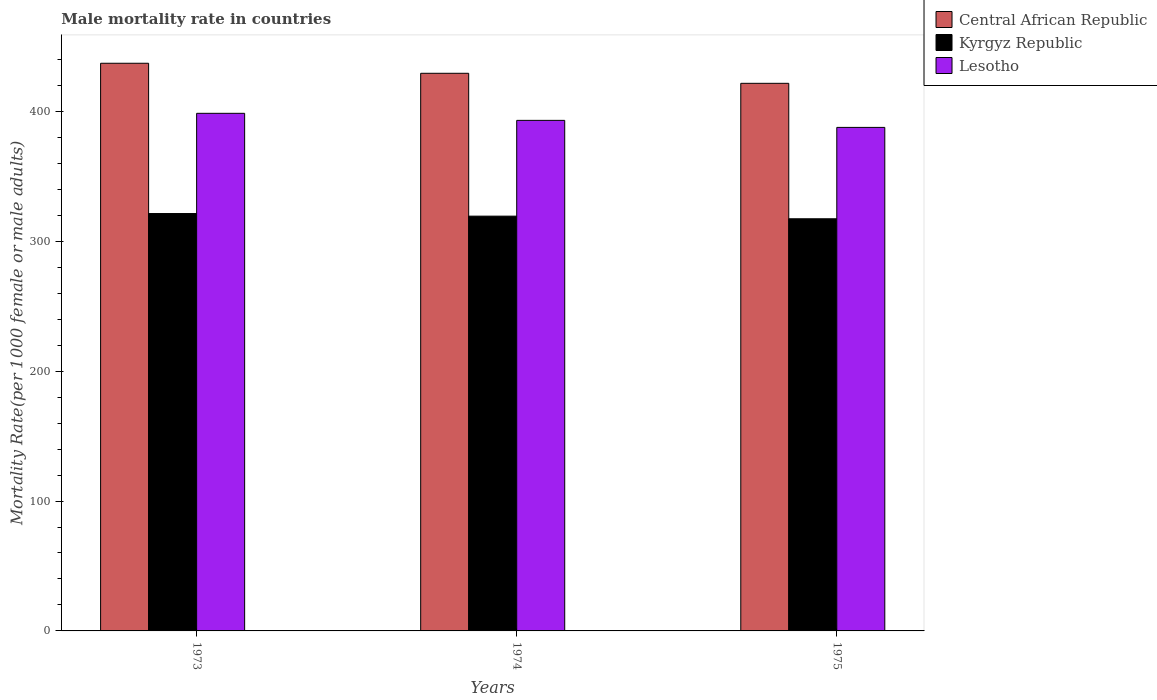What is the label of the 3rd group of bars from the left?
Give a very brief answer. 1975. What is the male mortality rate in Central African Republic in 1974?
Your answer should be very brief. 429.28. Across all years, what is the maximum male mortality rate in Kyrgyz Republic?
Your response must be concise. 321.32. Across all years, what is the minimum male mortality rate in Central African Republic?
Your answer should be compact. 421.56. In which year was the male mortality rate in Kyrgyz Republic maximum?
Make the answer very short. 1973. In which year was the male mortality rate in Kyrgyz Republic minimum?
Your answer should be very brief. 1975. What is the total male mortality rate in Lesotho in the graph?
Ensure brevity in your answer.  1179.13. What is the difference between the male mortality rate in Lesotho in 1974 and that in 1975?
Keep it short and to the point. 5.42. What is the difference between the male mortality rate in Kyrgyz Republic in 1975 and the male mortality rate in Lesotho in 1974?
Your response must be concise. -75.76. What is the average male mortality rate in Kyrgyz Republic per year?
Make the answer very short. 319.3. In the year 1975, what is the difference between the male mortality rate in Lesotho and male mortality rate in Central African Republic?
Make the answer very short. -33.93. In how many years, is the male mortality rate in Central African Republic greater than 180?
Keep it short and to the point. 3. What is the ratio of the male mortality rate in Central African Republic in 1974 to that in 1975?
Give a very brief answer. 1.02. Is the difference between the male mortality rate in Lesotho in 1973 and 1975 greater than the difference between the male mortality rate in Central African Republic in 1973 and 1975?
Keep it short and to the point. No. What is the difference between the highest and the second highest male mortality rate in Lesotho?
Make the answer very short. 5.42. What is the difference between the highest and the lowest male mortality rate in Lesotho?
Your answer should be very brief. 10.83. Is the sum of the male mortality rate in Lesotho in 1973 and 1975 greater than the maximum male mortality rate in Central African Republic across all years?
Make the answer very short. Yes. What does the 2nd bar from the left in 1975 represents?
Give a very brief answer. Kyrgyz Republic. What does the 3rd bar from the right in 1974 represents?
Your response must be concise. Central African Republic. Is it the case that in every year, the sum of the male mortality rate in Kyrgyz Republic and male mortality rate in Central African Republic is greater than the male mortality rate in Lesotho?
Give a very brief answer. Yes. Are all the bars in the graph horizontal?
Offer a terse response. No. Does the graph contain any zero values?
Ensure brevity in your answer.  No. Does the graph contain grids?
Provide a short and direct response. No. Where does the legend appear in the graph?
Keep it short and to the point. Top right. How are the legend labels stacked?
Offer a terse response. Vertical. What is the title of the graph?
Offer a terse response. Male mortality rate in countries. What is the label or title of the X-axis?
Ensure brevity in your answer.  Years. What is the label or title of the Y-axis?
Make the answer very short. Mortality Rate(per 1000 female or male adults). What is the Mortality Rate(per 1000 female or male adults) of Central African Republic in 1973?
Your response must be concise. 437. What is the Mortality Rate(per 1000 female or male adults) of Kyrgyz Republic in 1973?
Provide a short and direct response. 321.32. What is the Mortality Rate(per 1000 female or male adults) in Lesotho in 1973?
Give a very brief answer. 398.46. What is the Mortality Rate(per 1000 female or male adults) of Central African Republic in 1974?
Provide a short and direct response. 429.28. What is the Mortality Rate(per 1000 female or male adults) of Kyrgyz Republic in 1974?
Ensure brevity in your answer.  319.3. What is the Mortality Rate(per 1000 female or male adults) of Lesotho in 1974?
Ensure brevity in your answer.  393.05. What is the Mortality Rate(per 1000 female or male adults) in Central African Republic in 1975?
Your response must be concise. 421.56. What is the Mortality Rate(per 1000 female or male adults) in Kyrgyz Republic in 1975?
Your answer should be compact. 317.28. What is the Mortality Rate(per 1000 female or male adults) of Lesotho in 1975?
Make the answer very short. 387.63. Across all years, what is the maximum Mortality Rate(per 1000 female or male adults) of Central African Republic?
Keep it short and to the point. 437. Across all years, what is the maximum Mortality Rate(per 1000 female or male adults) of Kyrgyz Republic?
Make the answer very short. 321.32. Across all years, what is the maximum Mortality Rate(per 1000 female or male adults) in Lesotho?
Provide a succinct answer. 398.46. Across all years, what is the minimum Mortality Rate(per 1000 female or male adults) of Central African Republic?
Provide a short and direct response. 421.56. Across all years, what is the minimum Mortality Rate(per 1000 female or male adults) of Kyrgyz Republic?
Ensure brevity in your answer.  317.28. Across all years, what is the minimum Mortality Rate(per 1000 female or male adults) in Lesotho?
Keep it short and to the point. 387.63. What is the total Mortality Rate(per 1000 female or male adults) of Central African Republic in the graph?
Your answer should be very brief. 1287.85. What is the total Mortality Rate(per 1000 female or male adults) of Kyrgyz Republic in the graph?
Provide a succinct answer. 957.9. What is the total Mortality Rate(per 1000 female or male adults) in Lesotho in the graph?
Your answer should be compact. 1179.13. What is the difference between the Mortality Rate(per 1000 female or male adults) in Central African Republic in 1973 and that in 1974?
Make the answer very short. 7.72. What is the difference between the Mortality Rate(per 1000 female or male adults) in Kyrgyz Republic in 1973 and that in 1974?
Offer a very short reply. 2.02. What is the difference between the Mortality Rate(per 1000 female or male adults) in Lesotho in 1973 and that in 1974?
Provide a succinct answer. 5.42. What is the difference between the Mortality Rate(per 1000 female or male adults) of Central African Republic in 1973 and that in 1975?
Give a very brief answer. 15.45. What is the difference between the Mortality Rate(per 1000 female or male adults) of Kyrgyz Republic in 1973 and that in 1975?
Offer a terse response. 4.04. What is the difference between the Mortality Rate(per 1000 female or male adults) in Lesotho in 1973 and that in 1975?
Keep it short and to the point. 10.84. What is the difference between the Mortality Rate(per 1000 female or male adults) of Central African Republic in 1974 and that in 1975?
Keep it short and to the point. 7.72. What is the difference between the Mortality Rate(per 1000 female or male adults) of Kyrgyz Republic in 1974 and that in 1975?
Provide a succinct answer. 2.02. What is the difference between the Mortality Rate(per 1000 female or male adults) in Lesotho in 1974 and that in 1975?
Provide a succinct answer. 5.42. What is the difference between the Mortality Rate(per 1000 female or male adults) of Central African Republic in 1973 and the Mortality Rate(per 1000 female or male adults) of Kyrgyz Republic in 1974?
Give a very brief answer. 117.7. What is the difference between the Mortality Rate(per 1000 female or male adults) in Central African Republic in 1973 and the Mortality Rate(per 1000 female or male adults) in Lesotho in 1974?
Provide a succinct answer. 43.96. What is the difference between the Mortality Rate(per 1000 female or male adults) in Kyrgyz Republic in 1973 and the Mortality Rate(per 1000 female or male adults) in Lesotho in 1974?
Offer a terse response. -71.73. What is the difference between the Mortality Rate(per 1000 female or male adults) in Central African Republic in 1973 and the Mortality Rate(per 1000 female or male adults) in Kyrgyz Republic in 1975?
Provide a short and direct response. 119.72. What is the difference between the Mortality Rate(per 1000 female or male adults) in Central African Republic in 1973 and the Mortality Rate(per 1000 female or male adults) in Lesotho in 1975?
Offer a very short reply. 49.38. What is the difference between the Mortality Rate(per 1000 female or male adults) of Kyrgyz Republic in 1973 and the Mortality Rate(per 1000 female or male adults) of Lesotho in 1975?
Make the answer very short. -66.31. What is the difference between the Mortality Rate(per 1000 female or male adults) in Central African Republic in 1974 and the Mortality Rate(per 1000 female or male adults) in Kyrgyz Republic in 1975?
Your answer should be very brief. 112. What is the difference between the Mortality Rate(per 1000 female or male adults) in Central African Republic in 1974 and the Mortality Rate(per 1000 female or male adults) in Lesotho in 1975?
Keep it short and to the point. 41.66. What is the difference between the Mortality Rate(per 1000 female or male adults) of Kyrgyz Republic in 1974 and the Mortality Rate(per 1000 female or male adults) of Lesotho in 1975?
Provide a succinct answer. -68.33. What is the average Mortality Rate(per 1000 female or male adults) in Central African Republic per year?
Provide a short and direct response. 429.28. What is the average Mortality Rate(per 1000 female or male adults) of Kyrgyz Republic per year?
Offer a terse response. 319.3. What is the average Mortality Rate(per 1000 female or male adults) in Lesotho per year?
Make the answer very short. 393.04. In the year 1973, what is the difference between the Mortality Rate(per 1000 female or male adults) of Central African Republic and Mortality Rate(per 1000 female or male adults) of Kyrgyz Republic?
Keep it short and to the point. 115.69. In the year 1973, what is the difference between the Mortality Rate(per 1000 female or male adults) in Central African Republic and Mortality Rate(per 1000 female or male adults) in Lesotho?
Your response must be concise. 38.54. In the year 1973, what is the difference between the Mortality Rate(per 1000 female or male adults) of Kyrgyz Republic and Mortality Rate(per 1000 female or male adults) of Lesotho?
Your answer should be very brief. -77.14. In the year 1974, what is the difference between the Mortality Rate(per 1000 female or male adults) of Central African Republic and Mortality Rate(per 1000 female or male adults) of Kyrgyz Republic?
Your answer should be very brief. 109.98. In the year 1974, what is the difference between the Mortality Rate(per 1000 female or male adults) of Central African Republic and Mortality Rate(per 1000 female or male adults) of Lesotho?
Provide a succinct answer. 36.24. In the year 1974, what is the difference between the Mortality Rate(per 1000 female or male adults) in Kyrgyz Republic and Mortality Rate(per 1000 female or male adults) in Lesotho?
Your answer should be compact. -73.75. In the year 1975, what is the difference between the Mortality Rate(per 1000 female or male adults) in Central African Republic and Mortality Rate(per 1000 female or male adults) in Kyrgyz Republic?
Offer a very short reply. 104.28. In the year 1975, what is the difference between the Mortality Rate(per 1000 female or male adults) of Central African Republic and Mortality Rate(per 1000 female or male adults) of Lesotho?
Your answer should be very brief. 33.93. In the year 1975, what is the difference between the Mortality Rate(per 1000 female or male adults) of Kyrgyz Republic and Mortality Rate(per 1000 female or male adults) of Lesotho?
Your answer should be compact. -70.35. What is the ratio of the Mortality Rate(per 1000 female or male adults) in Central African Republic in 1973 to that in 1974?
Make the answer very short. 1.02. What is the ratio of the Mortality Rate(per 1000 female or male adults) of Kyrgyz Republic in 1973 to that in 1974?
Offer a terse response. 1.01. What is the ratio of the Mortality Rate(per 1000 female or male adults) of Lesotho in 1973 to that in 1974?
Provide a succinct answer. 1.01. What is the ratio of the Mortality Rate(per 1000 female or male adults) in Central African Republic in 1973 to that in 1975?
Provide a short and direct response. 1.04. What is the ratio of the Mortality Rate(per 1000 female or male adults) of Kyrgyz Republic in 1973 to that in 1975?
Give a very brief answer. 1.01. What is the ratio of the Mortality Rate(per 1000 female or male adults) of Lesotho in 1973 to that in 1975?
Provide a short and direct response. 1.03. What is the ratio of the Mortality Rate(per 1000 female or male adults) in Central African Republic in 1974 to that in 1975?
Your answer should be very brief. 1.02. What is the ratio of the Mortality Rate(per 1000 female or male adults) of Kyrgyz Republic in 1974 to that in 1975?
Keep it short and to the point. 1.01. What is the difference between the highest and the second highest Mortality Rate(per 1000 female or male adults) of Central African Republic?
Offer a very short reply. 7.72. What is the difference between the highest and the second highest Mortality Rate(per 1000 female or male adults) of Kyrgyz Republic?
Make the answer very short. 2.02. What is the difference between the highest and the second highest Mortality Rate(per 1000 female or male adults) of Lesotho?
Your response must be concise. 5.42. What is the difference between the highest and the lowest Mortality Rate(per 1000 female or male adults) of Central African Republic?
Provide a short and direct response. 15.45. What is the difference between the highest and the lowest Mortality Rate(per 1000 female or male adults) of Kyrgyz Republic?
Your response must be concise. 4.04. What is the difference between the highest and the lowest Mortality Rate(per 1000 female or male adults) of Lesotho?
Provide a short and direct response. 10.84. 